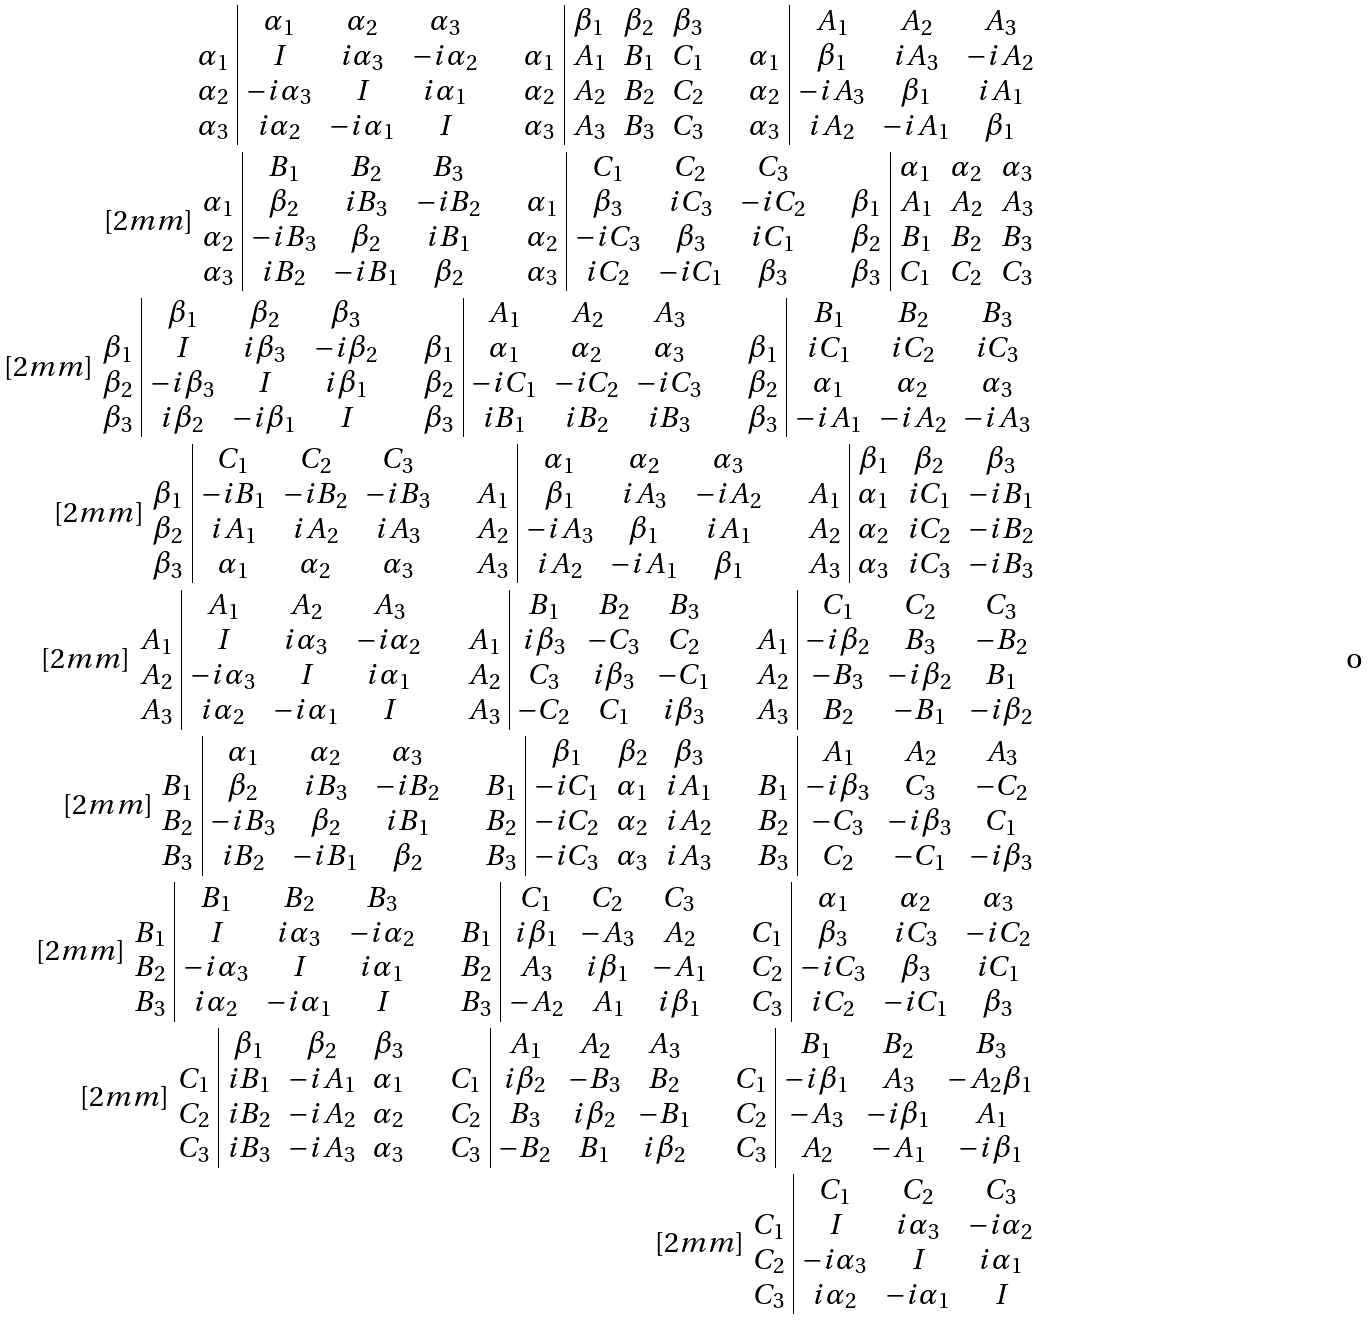Convert formula to latex. <formula><loc_0><loc_0><loc_500><loc_500>\begin{array} { c | c c c } & \alpha _ { 1 } & \alpha _ { 2 } & \alpha _ { 3 } \\ \alpha _ { 1 } & I & i \alpha _ { 3 } & - i \alpha _ { 2 } \\ \alpha _ { 2 } & - i \alpha _ { 3 } & I & i \alpha _ { 1 } \\ \alpha _ { 3 } & i \alpha _ { 2 } & - i \alpha _ { 1 } & I \end{array} \quad \begin{array} { c | c c c } & \beta _ { 1 } & \beta _ { 2 } & \beta _ { 3 } \\ \alpha _ { 1 } & A _ { 1 } & B _ { 1 } & C _ { 1 } \\ \alpha _ { 2 } & A _ { 2 } & B _ { 2 } & C _ { 2 } \\ \alpha _ { 3 } & A _ { 3 } & B _ { 3 } & C _ { 3 } \end{array} \quad \begin{array} { c | c c c } & A _ { 1 } & A _ { 2 } & A _ { 3 } \\ \alpha _ { 1 } & \beta _ { 1 } & i A _ { 3 } & - i A _ { 2 } \\ \alpha _ { 2 } & - i A _ { 3 } & \beta _ { 1 } & i A _ { 1 } \\ \alpha _ { 3 } & i A _ { 2 } & - i A _ { 1 } & \beta _ { 1 } \end{array} \\ [ 2 m m ] \begin{array} { c | c c c } & B _ { 1 } & B _ { 2 } & B _ { 3 } \\ \alpha _ { 1 } & \beta _ { 2 } & i B _ { 3 } & - i B _ { 2 } \\ \alpha _ { 2 } & - i B _ { 3 } & \beta _ { 2 } & i B _ { 1 } \\ \alpha _ { 3 } & i B _ { 2 } & - i B _ { 1 } & \beta _ { 2 } \end{array} \quad \begin{array} { c | c c c } & C _ { 1 } & C _ { 2 } & C _ { 3 } \\ \alpha _ { 1 } & \beta _ { 3 } & i C _ { 3 } & - i C _ { 2 } \\ \alpha _ { 2 } & - i C _ { 3 } & \beta _ { 3 } & i C _ { 1 } \\ \alpha _ { 3 } & i C _ { 2 } & - i C _ { 1 } & \beta _ { 3 } \end{array} \quad \begin{array} { c | c c c } & \alpha _ { 1 } & \alpha _ { 2 } & \alpha _ { 3 } \\ \beta _ { 1 } & A _ { 1 } & A _ { 2 } & A _ { 3 } \\ \beta _ { 2 } & B _ { 1 } & B _ { 2 } & B _ { 3 } \\ \beta _ { 3 } & C _ { 1 } & C _ { 2 } & C _ { 3 } \end{array} \\ [ 2 m m ] \begin{array} { c | c c c } & \beta _ { 1 } & \beta _ { 2 } & \beta _ { 3 } \\ \beta _ { 1 } & I & i \beta _ { 3 } & - i \beta _ { 2 } \\ \beta _ { 2 } & - i \beta _ { 3 } & I & i \beta _ { 1 } \\ \beta _ { 3 } & i \beta _ { 2 } & - i \beta _ { 1 } & I \end{array} \quad \begin{array} { c | c c c } & A _ { 1 } & A _ { 2 } & A _ { 3 } \\ \beta _ { 1 } & \alpha _ { 1 } & \alpha _ { 2 } & \alpha _ { 3 } \\ \beta _ { 2 } & - i C _ { 1 } & - i C _ { 2 } & - i C _ { 3 } \\ \beta _ { 3 } & i B _ { 1 } & i B _ { 2 } & i B _ { 3 } \end{array} \quad \begin{array} { c | c c c } & B _ { 1 } & B _ { 2 } & B _ { 3 } \\ \beta _ { 1 } & i C _ { 1 } & i C _ { 2 } & i C _ { 3 } \\ \beta _ { 2 } & \alpha _ { 1 } & \alpha _ { 2 } & \alpha _ { 3 } \\ \beta _ { 3 } & - i A _ { 1 } & - i A _ { 2 } & - i A _ { 3 } \end{array} \, \\ [ 2 m m ] \begin{array} { c | c c c } & C _ { 1 } & C _ { 2 } & C _ { 3 } \\ \beta _ { 1 } & - i B _ { 1 } & - i B _ { 2 } & - i B _ { 3 } \\ \beta _ { 2 } & i A _ { 1 } & i A _ { 2 } & i A _ { 3 } \\ \beta _ { 3 } & \alpha _ { 1 } & \alpha _ { 2 } & \alpha _ { 3 } \end{array} \quad \begin{array} { c | c c c } & \alpha _ { 1 } & \alpha _ { 2 } & \alpha _ { 3 } \\ A _ { 1 } & \beta _ { 1 } & i A _ { 3 } & - i A _ { 2 } \\ A _ { 2 } & - i A _ { 3 } & \beta _ { 1 } & i A _ { 1 } \\ A _ { 3 } & i A _ { 2 } & - i A _ { 1 } & \beta _ { 1 } \end{array} \quad \begin{array} { c | c c c } & \beta _ { 1 } & \beta _ { 2 } & \beta _ { 3 } \\ A _ { 1 } & \alpha _ { 1 } & i C _ { 1 } & - i B _ { 1 } \\ A _ { 2 } & \alpha _ { 2 } & i C _ { 2 } & - i B _ { 2 } \\ A _ { 3 } & \alpha _ { 3 } & i C _ { 3 } & - i B _ { 3 } \end{array} \\ [ 2 m m ] \begin{array} { c | c c c } & A _ { 1 } & A _ { 2 } & A _ { 3 } \\ A _ { 1 } & I & i \alpha _ { 3 } & - i \alpha _ { 2 } \\ A _ { 2 } & - i \alpha _ { 3 } & I & i \alpha _ { 1 } \\ A _ { 3 } & i \alpha _ { 2 } & - i \alpha _ { 1 } & I \end{array} \quad \begin{array} { c | c c c } & B _ { 1 } & B _ { 2 } & B _ { 3 } \\ A _ { 1 } & i \beta _ { 3 } & - C _ { 3 } & C _ { 2 } \\ A _ { 2 } & C _ { 3 } & i \beta _ { 3 } & - C _ { 1 } \\ A _ { 3 } & - C _ { 2 } & C _ { 1 } & i \beta _ { 3 } \end{array} \quad \begin{array} { c | c c c } & C _ { 1 } & C _ { 2 } & C _ { 3 } \\ A _ { 1 } & - i \beta _ { 2 } & B _ { 3 } & - B _ { 2 } \\ A _ { 2 } & - B _ { 3 } & - i \beta _ { 2 } & B _ { 1 } \\ A _ { 3 } & B _ { 2 } & - B _ { 1 } & - i \beta _ { 2 } \end{array} \\ [ 2 m m ] \begin{array} { c | c c c } & \alpha _ { 1 } & \alpha _ { 2 } & \alpha _ { 3 } \\ B _ { 1 } & \beta _ { 2 } & i B _ { 3 } & - i B _ { 2 } \\ B _ { 2 } & - i B _ { 3 } & \beta _ { 2 } & i B _ { 1 } \\ B _ { 3 } & i B _ { 2 } & - i B _ { 1 } & \beta _ { 2 } \end{array} \quad \begin{array} { c | c c c } & \beta _ { 1 } & \beta _ { 2 } & \beta _ { 3 } \\ B _ { 1 } & - i C _ { 1 } & \alpha _ { 1 } & i A _ { 1 } \\ B _ { 2 } & - i C _ { 2 } & \alpha _ { 2 } & i A _ { 2 } \\ B _ { 3 } & - i C _ { 3 } & \alpha _ { 3 } & i A _ { 3 } \end{array} \quad \begin{array} { c | c c c } & A _ { 1 } & A _ { 2 } & A _ { 3 } \\ B _ { 1 } & - i \beta _ { 3 } & C _ { 3 } & - C _ { 2 } \\ B _ { 2 } & - C _ { 3 } & - i \beta _ { 3 } & C _ { 1 } \\ B _ { 3 } & C _ { 2 } & - C _ { 1 } & - i \beta _ { 3 } \end{array} \\ [ 2 m m ] \begin{array} { c | c c c } & B _ { 1 } & B _ { 2 } & B _ { 3 } \\ B _ { 1 } & I & i \alpha _ { 3 } & - i \alpha _ { 2 } \\ B _ { 2 } & - i \alpha _ { 3 } & I & i \alpha _ { 1 } \\ B _ { 3 } & i \alpha _ { 2 } & - i \alpha _ { 1 } & I \end{array} \quad \begin{array} { c | c c c } & C _ { 1 } & C _ { 2 } & C _ { 3 } \\ B _ { 1 } & i \beta _ { 1 } & - A _ { 3 } & A _ { 2 } \\ B _ { 2 } & A _ { 3 } & i \beta _ { 1 } & - A _ { 1 } \\ B _ { 3 } & - A _ { 2 } & A _ { 1 } & i \beta _ { 1 } \end{array} \quad \begin{array} { c | c c c } & \alpha _ { 1 } & \alpha _ { 2 } & \alpha _ { 3 } \\ C _ { 1 } & \beta _ { 3 } & i C _ { 3 } & - i C _ { 2 } \\ C _ { 2 } & - i C _ { 3 } & \beta _ { 3 } & i C _ { 1 } \\ C _ { 3 } & i C _ { 2 } & - i C _ { 1 } & \beta _ { 3 } \end{array} \, \\ [ 2 m m ] \begin{array} { c | c c c } & \beta _ { 1 } & \beta _ { 2 } & \beta _ { 3 } \\ C _ { 1 } & i B _ { 1 } & - i A _ { 1 } & \alpha _ { 1 } \\ C _ { 2 } & i B _ { 2 } & - i A _ { 2 } & \alpha _ { 2 } \\ C _ { 3 } & i B _ { 3 } & - i A _ { 3 } & \alpha _ { 3 } \end{array} \quad \begin{array} { c | c c c } & A _ { 1 } & A _ { 2 } & A _ { 3 } \\ C _ { 1 } & i \beta _ { 2 } & - B _ { 3 } & B _ { 2 } \\ C _ { 2 } & B _ { 3 } & i \beta _ { 2 } & - B _ { 1 } \\ C _ { 3 } & - B _ { 2 } & B _ { 1 } & i \beta _ { 2 } \end{array} \quad \begin{array} { c | c c c } & B _ { 1 } & B _ { 2 } & B _ { 3 } \\ C _ { 1 } & - i \beta _ { 1 } & A _ { 3 } & - A _ { 2 } \beta _ { 1 } \\ C _ { 2 } & - A _ { 3 } & - i \beta _ { 1 } & A _ { 1 } \\ C _ { 3 } & A _ { 2 } & - A _ { 1 } & - i \beta _ { 1 } \end{array} \\ [ 2 m m ] \begin{array} { c | c c c } & C _ { 1 } & C _ { 2 } & C _ { 3 } \\ C _ { 1 } & I & i \alpha _ { 3 } & - i \alpha _ { 2 } \\ C _ { 2 } & - i \alpha _ { 3 } & I & i \alpha _ { 1 } \\ C _ { 3 } & i \alpha _ { 2 } & - i \alpha _ { 1 } & I \end{array}</formula> 